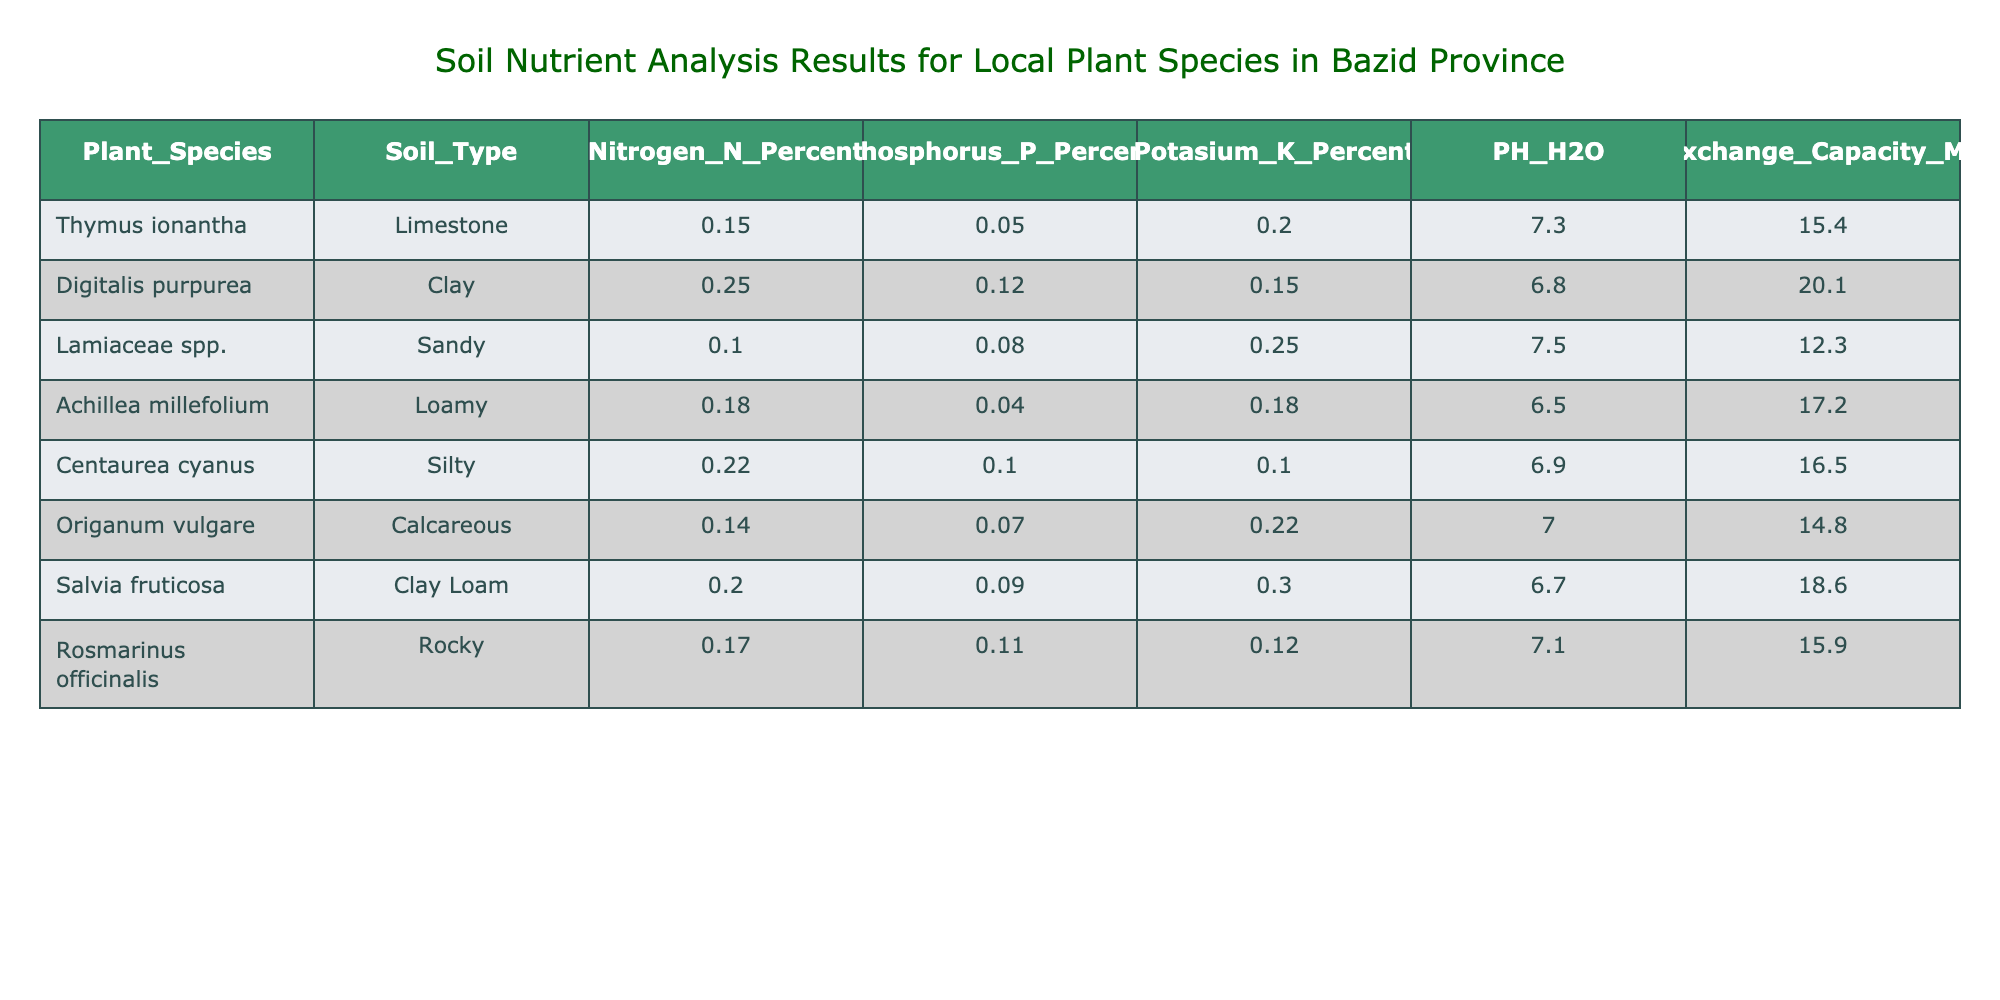What is the nitrogen percentage in Digitalis purpurea? The table directly provides the nitrogen percentage for each plant species. For Digitalis purpurea, it is listed as 0.25 percent.
Answer: 0.25 Which plant species has the highest potassium percentage? By examining the potassium percentage column, we see that Salvia fruticosa has the highest value at 0.30 percent, higher than all other species listed.
Answer: Salvia fruticosa What is the average pH value of the soil types? We sum the pH values of all the soil types (7.3 + 6.8 + 7.5 + 6.5 + 6.9 + 7.0 + 6.7 + 7.1 = 54.8). Then, we divide by the number of species (8). So, average pH = 54.8 / 8 = 6.85.
Answer: 6.85 Is there a plant species that has a nitrogen percentage greater than 0.20? By checking the nitrogen percentages, we find that Digitalis purpurea (0.25) and Centaurea cyanus (0.22) both have values greater than 0.20. Hence, the statement is true.
Answer: Yes Which soil type is associated with the highest cation exchange capacity? Looking at the cation exchange capacity column, clay has the highest value of 20.1 MEq/100g, corresponding to Digitalis purpurea.
Answer: Clay 